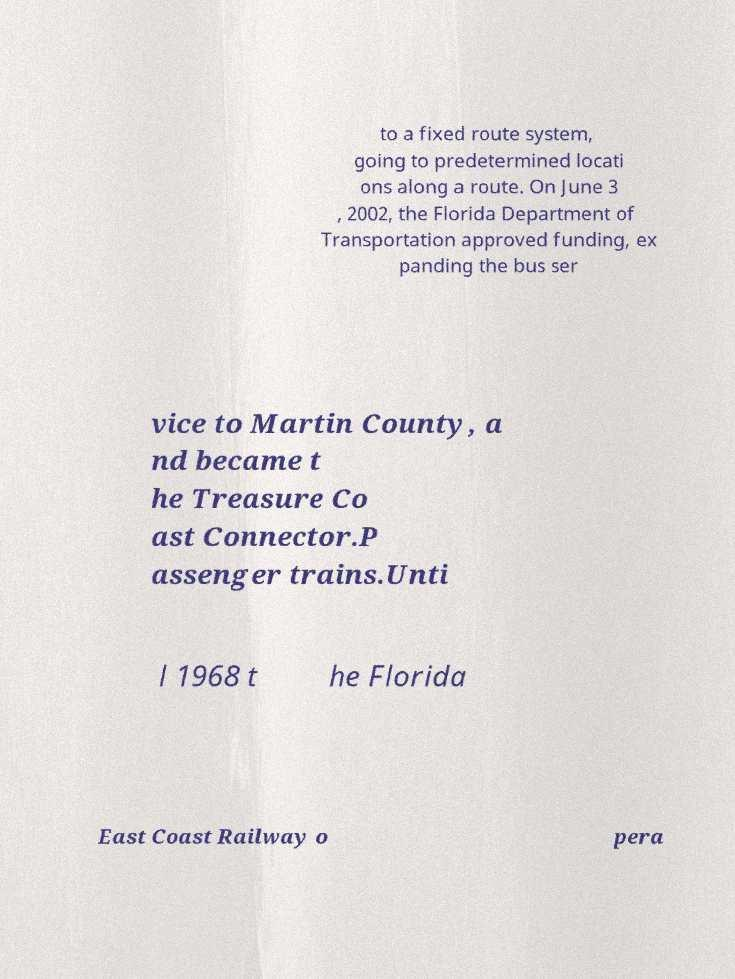I need the written content from this picture converted into text. Can you do that? to a fixed route system, going to predetermined locati ons along a route. On June 3 , 2002, the Florida Department of Transportation approved funding, ex panding the bus ser vice to Martin County, a nd became t he Treasure Co ast Connector.P assenger trains.Unti l 1968 t he Florida East Coast Railway o pera 